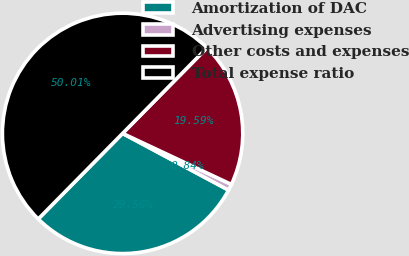Convert chart to OTSL. <chart><loc_0><loc_0><loc_500><loc_500><pie_chart><fcel>Amortization of DAC<fcel>Advertising expenses<fcel>Other costs and expenses<fcel>Total expense ratio<nl><fcel>29.56%<fcel>0.84%<fcel>19.59%<fcel>50.0%<nl></chart> 